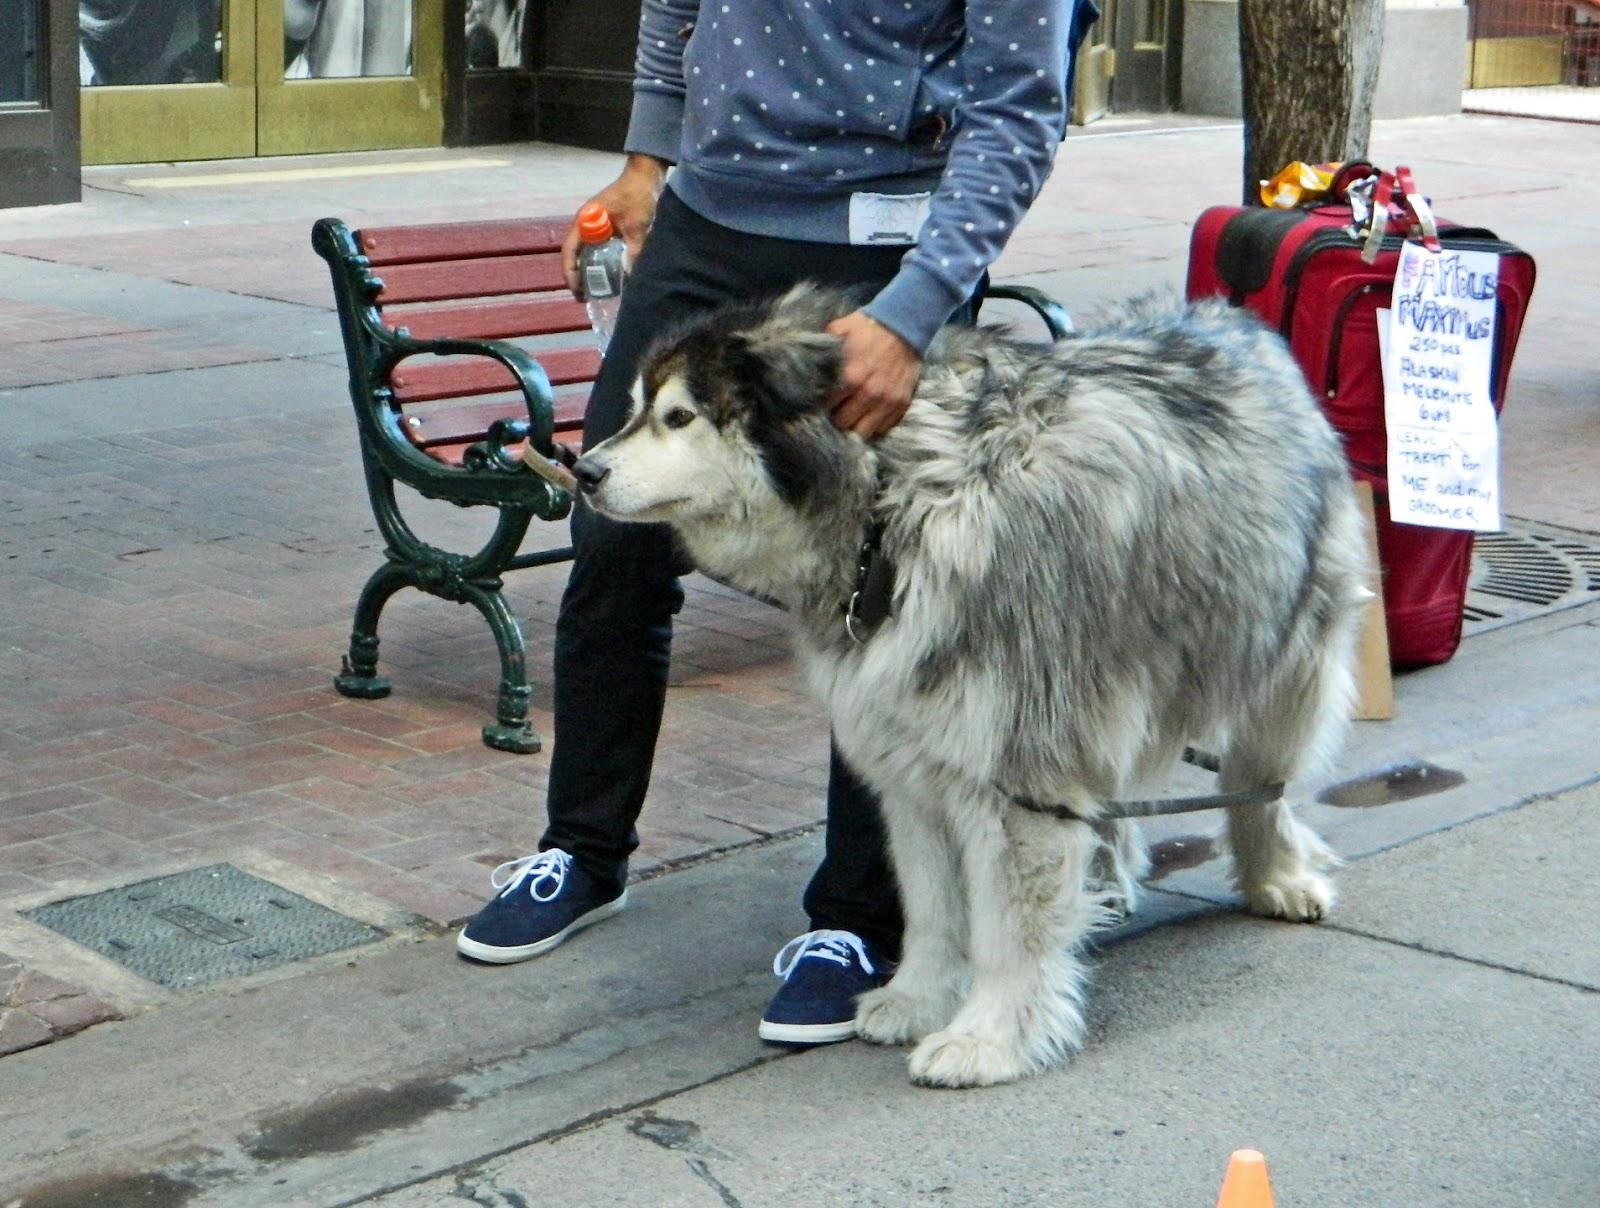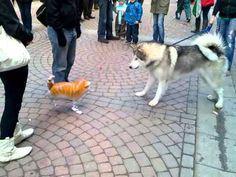The first image is the image on the left, the second image is the image on the right. Given the left and right images, does the statement "One of the images shows exactly five puppies." hold true? Answer yes or no. No. The first image is the image on the left, the second image is the image on the right. Examine the images to the left and right. Is the description "At least one person is standing directly next to a standing, leftward-facing husky in the left image." accurate? Answer yes or no. Yes. 